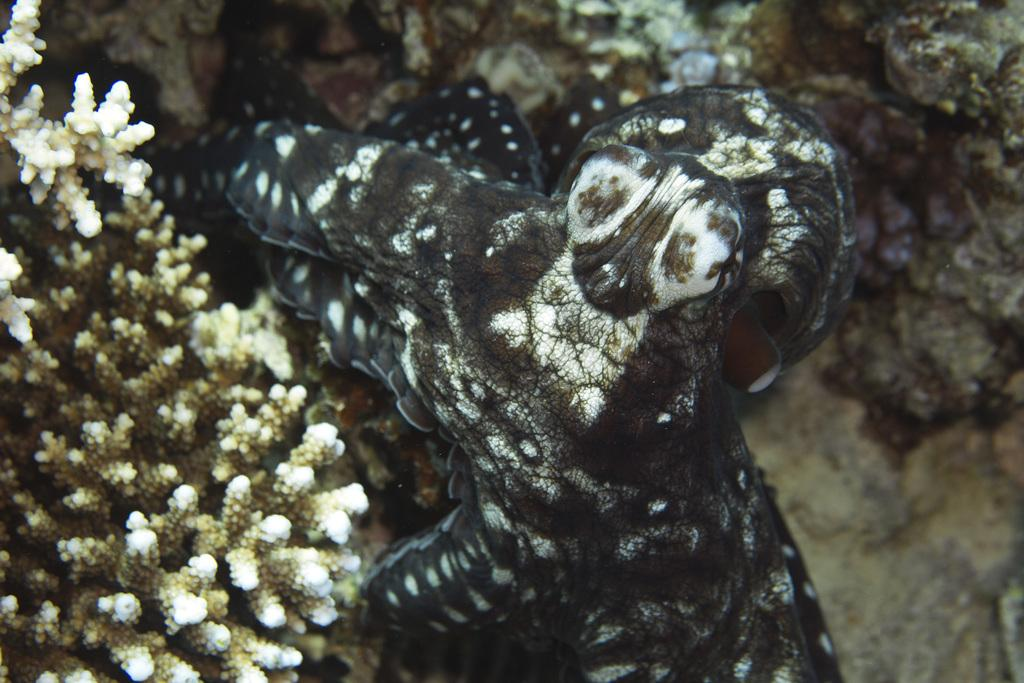What type of animal is in the image? The type of animal cannot be determined from the provided facts. What can be seen on the left side of the image? There are corals on the left side of the image. What is present on the right side of the image? There are stones on the right side of the image. What type of authority is depicted in the image? There is no authority figure present in the image. Is there a jail visible in the image? There is no jail present in the image. 